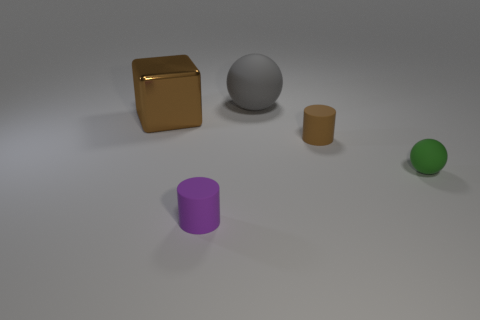Add 4 brown objects. How many objects exist? 9 Subtract all balls. How many objects are left? 3 Subtract all cyan cylinders. How many green balls are left? 1 Subtract all large blue rubber cubes. Subtract all small brown cylinders. How many objects are left? 4 Add 1 purple cylinders. How many purple cylinders are left? 2 Add 4 metal blocks. How many metal blocks exist? 5 Subtract 0 brown spheres. How many objects are left? 5 Subtract 1 cubes. How many cubes are left? 0 Subtract all yellow balls. Subtract all blue cylinders. How many balls are left? 2 